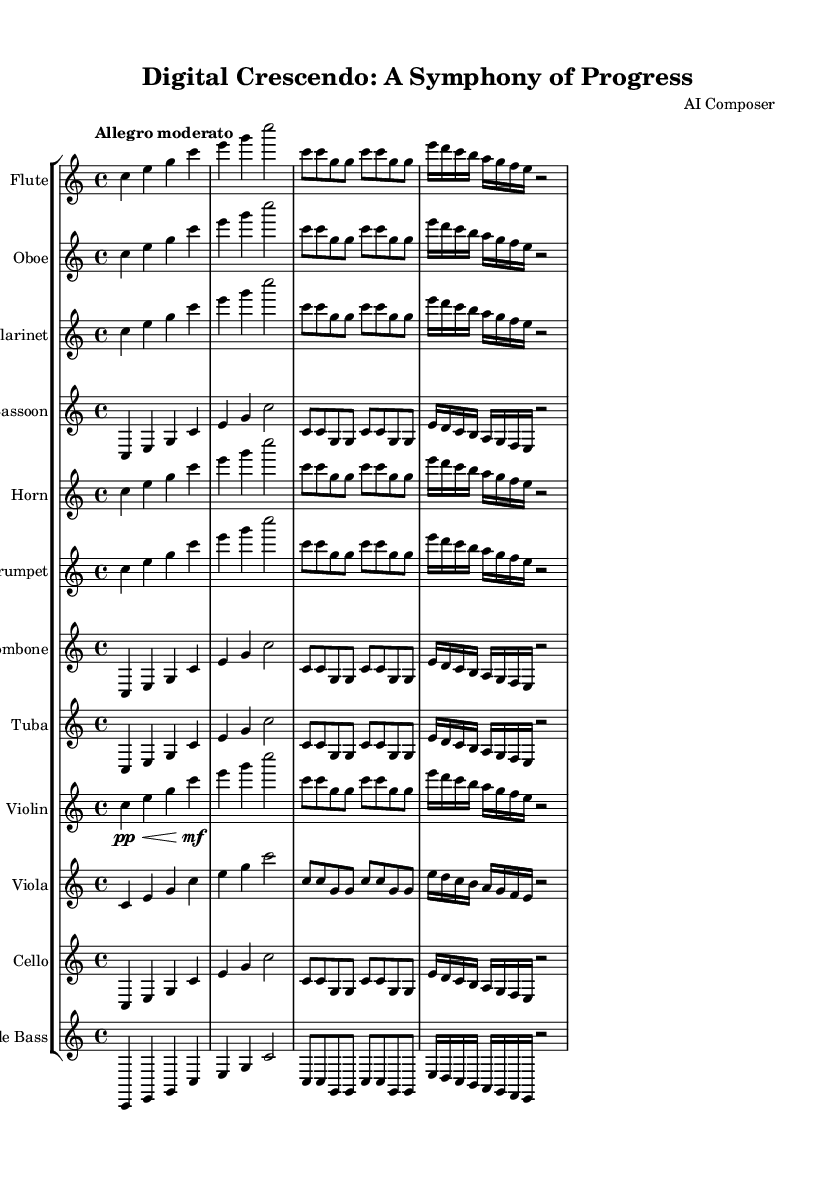what is the title of this symphony? The title is listed at the top of the sheet music under the header section. It reads "Digital Crescendo: A Symphony of Progress."
Answer: Digital Crescendo: A Symphony of Progress what is the key signature of this music? The key signature indicated for this symphony is C major, which is shown by the absence of any sharps or flats at the beginning of the staff lines.
Answer: C major what is the time signature of the symphony? The time signature is displayed as 4/4, indicating that there are four beats in each measure and a quarter note receives one beat.
Answer: 4/4 what is the tempo marking for this piece? The tempo marking can be found under the global settings, specifically noted as "Allegro moderato," which indicates a moderately fast tempo.
Answer: Allegro moderato how many different instruments are included in the symphony? By counting the number of staves in the score section, each representing a different instrument, we see there are a total of twelve instruments listed.
Answer: 12 which instruments are in the woodwind section? The woodwind instruments are indicated by the specific staves: Flute, Oboe, Clarinet, and Bassoon, as they are recognized as part of the woodwind family.
Answer: Flute, Oboe, Clarinet, Bassoon does this symphony include dynamic markings? Yes, dynamic markings are present, indicated by symbols such as "pp" for pianissimo and "mf" for mezzo-forte, specifically in reference to the Violin part.
Answer: Yes 